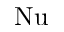<formula> <loc_0><loc_0><loc_500><loc_500>N u</formula> 